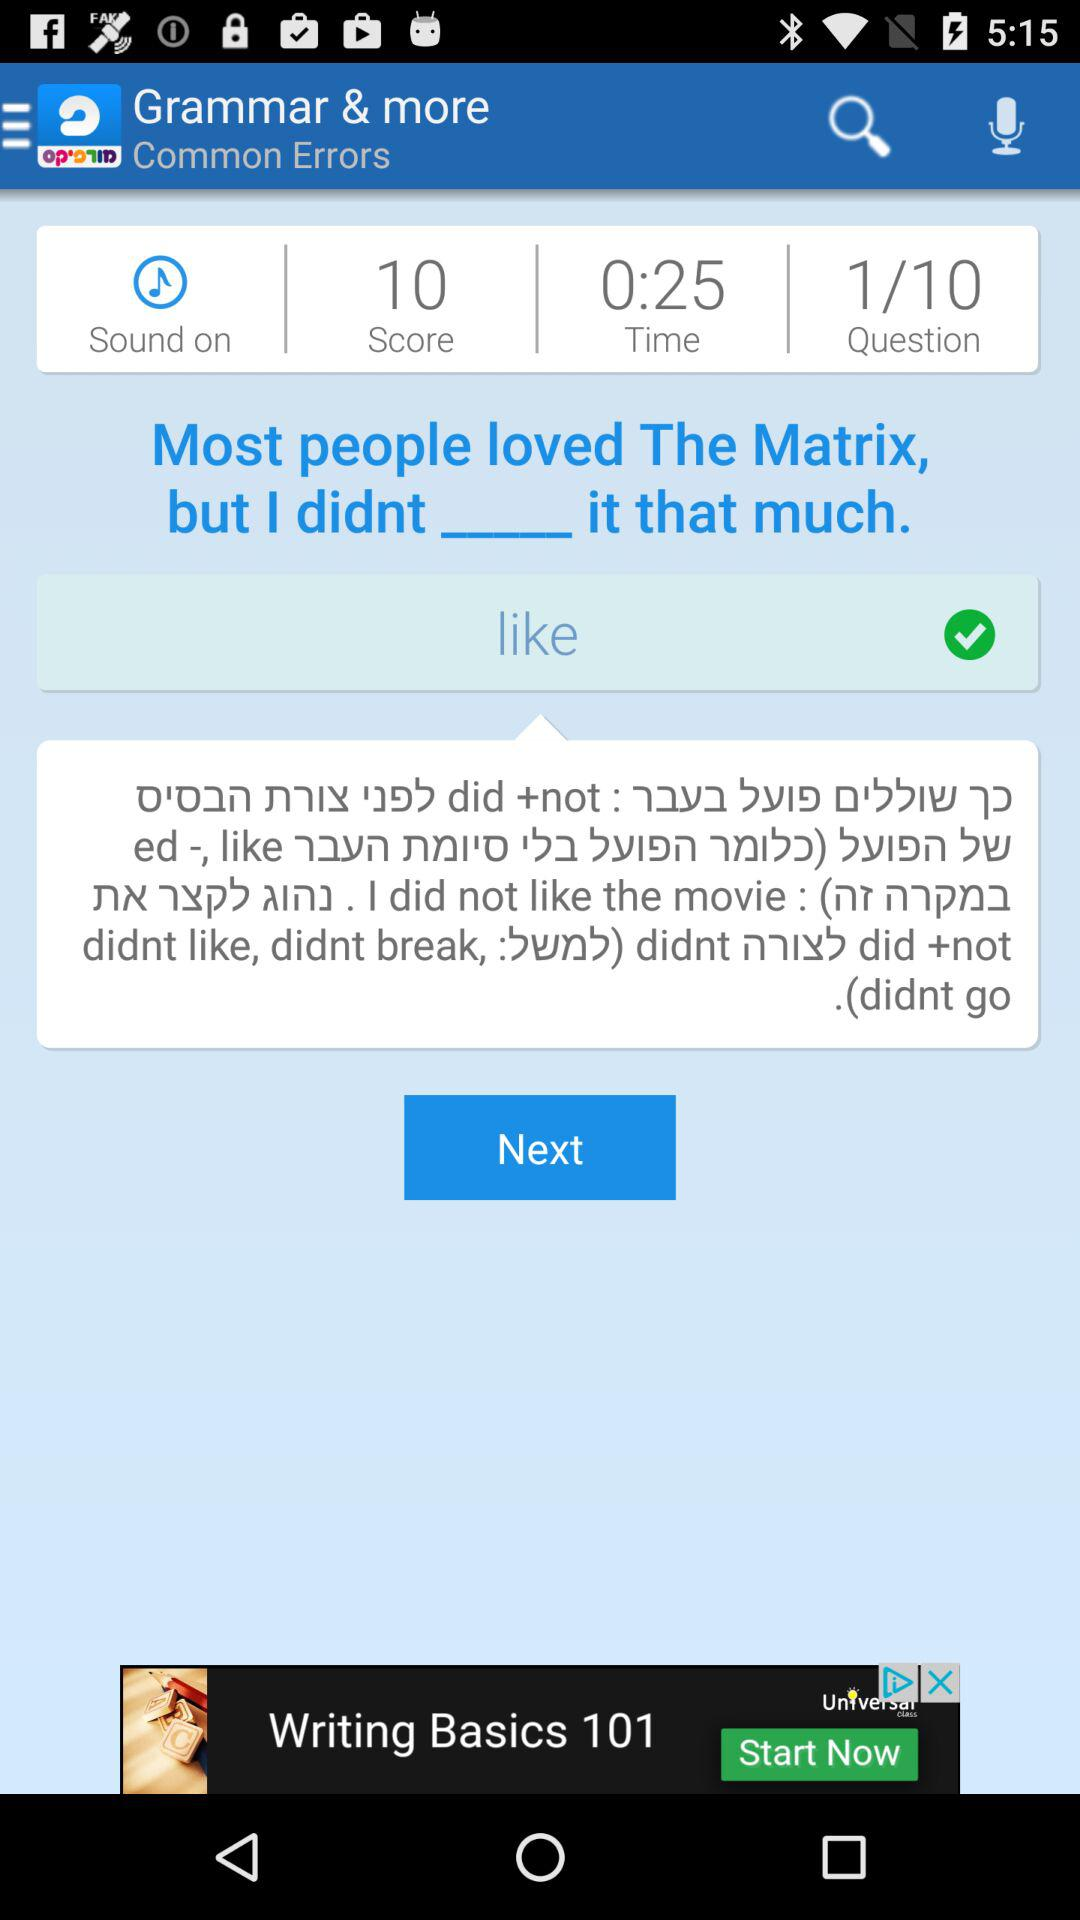How much time is left? There are 25 seconds left. 